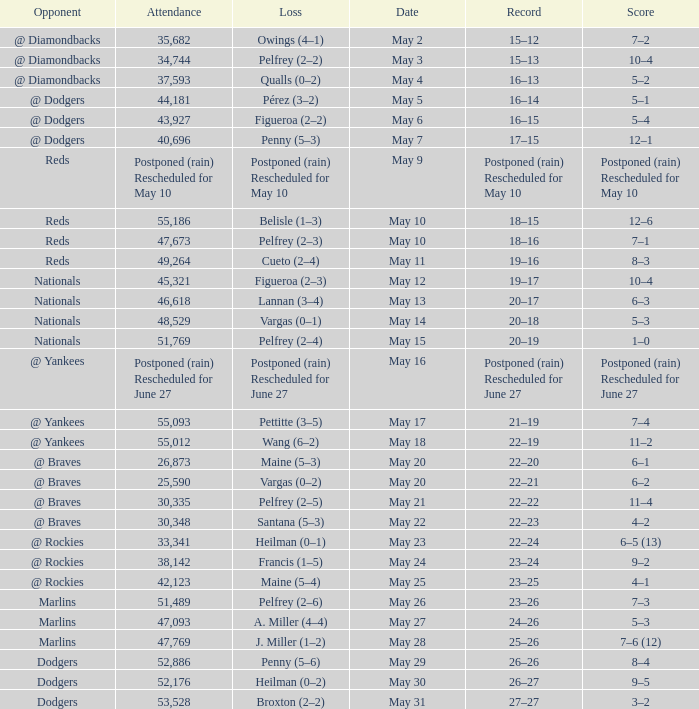Opponent of @ braves, and a Loss of pelfrey (2–5) had what score? 11–4. 